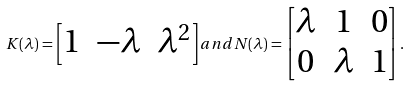<formula> <loc_0><loc_0><loc_500><loc_500>K ( \lambda ) = \begin{bmatrix} 1 & - \lambda & \lambda ^ { 2 } \end{bmatrix} a n d N ( \lambda ) = \begin{bmatrix} \lambda & 1 & 0 \\ 0 & \lambda & 1 \end{bmatrix} .</formula> 